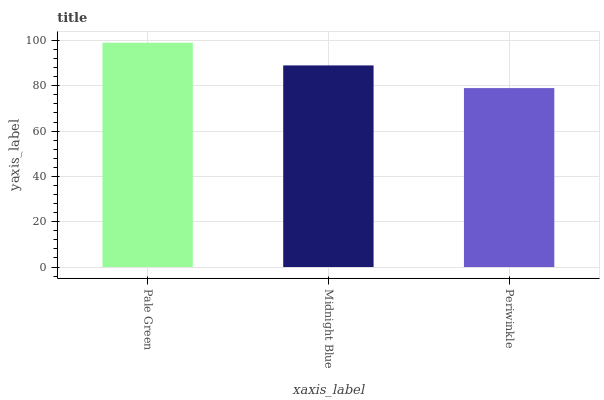Is Midnight Blue the minimum?
Answer yes or no. No. Is Midnight Blue the maximum?
Answer yes or no. No. Is Pale Green greater than Midnight Blue?
Answer yes or no. Yes. Is Midnight Blue less than Pale Green?
Answer yes or no. Yes. Is Midnight Blue greater than Pale Green?
Answer yes or no. No. Is Pale Green less than Midnight Blue?
Answer yes or no. No. Is Midnight Blue the high median?
Answer yes or no. Yes. Is Midnight Blue the low median?
Answer yes or no. Yes. Is Periwinkle the high median?
Answer yes or no. No. Is Pale Green the low median?
Answer yes or no. No. 